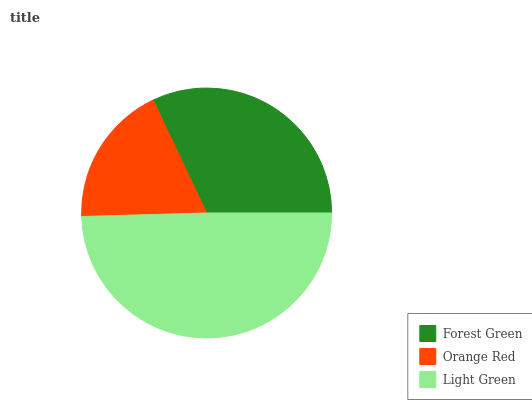Is Orange Red the minimum?
Answer yes or no. Yes. Is Light Green the maximum?
Answer yes or no. Yes. Is Light Green the minimum?
Answer yes or no. No. Is Orange Red the maximum?
Answer yes or no. No. Is Light Green greater than Orange Red?
Answer yes or no. Yes. Is Orange Red less than Light Green?
Answer yes or no. Yes. Is Orange Red greater than Light Green?
Answer yes or no. No. Is Light Green less than Orange Red?
Answer yes or no. No. Is Forest Green the high median?
Answer yes or no. Yes. Is Forest Green the low median?
Answer yes or no. Yes. Is Orange Red the high median?
Answer yes or no. No. Is Orange Red the low median?
Answer yes or no. No. 